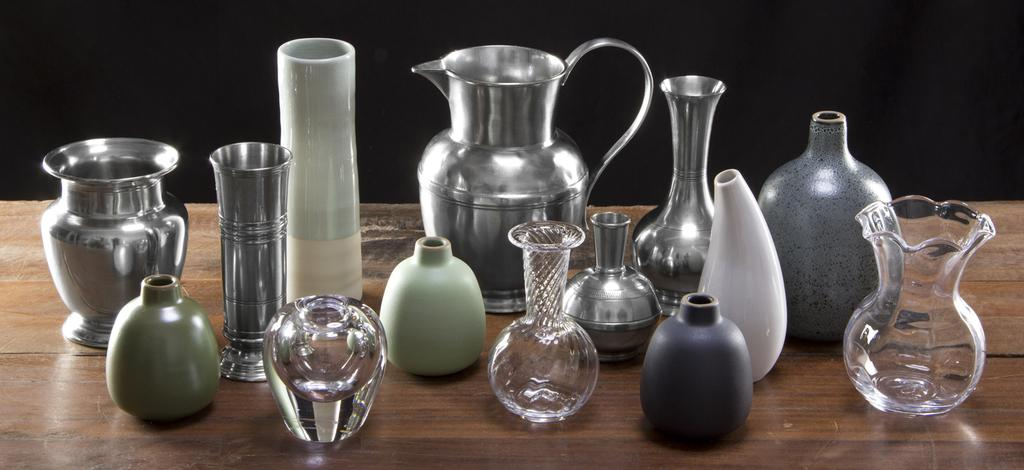What type of furniture is present in the image? There is a table in the image. What items can be seen on the table? There are a few jars, a jug, a pot, and a few unspecified things on the table. How does the table feel about its own existence in the image? The table is an inanimate object and does not have feelings or thoughts about its existence. What is the size of the water in the image? There is no water present in the image. 